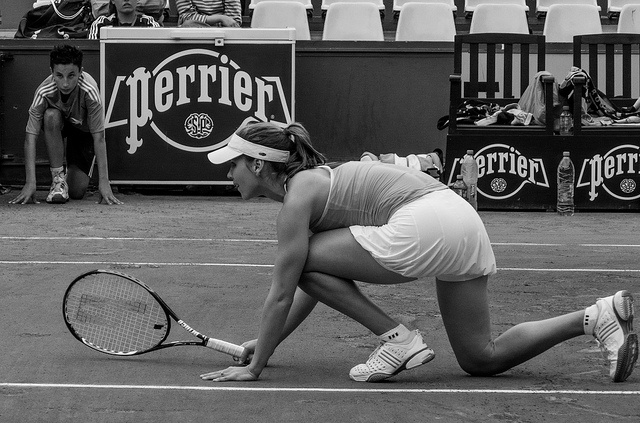Describe the objects in this image and their specific colors. I can see people in gray, black, darkgray, and lightgray tones, people in gray, black, darkgray, and lightgray tones, chair in gray, black, and lightgray tones, tennis racket in gray, black, and gainsboro tones, and chair in gray, black, and lightgray tones in this image. 